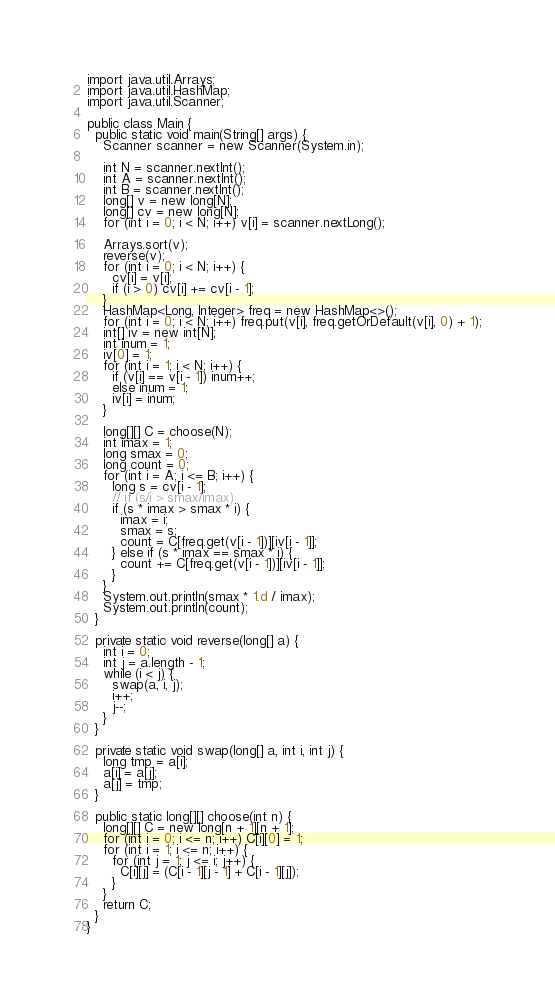Convert code to text. <code><loc_0><loc_0><loc_500><loc_500><_Java_>import java.util.Arrays;
import java.util.HashMap;
import java.util.Scanner;

public class Main {
  public static void main(String[] args) {
    Scanner scanner = new Scanner(System.in);

    int N = scanner.nextInt();
    int A = scanner.nextInt();
    int B = scanner.nextInt();
    long[] v = new long[N];
    long[] cv = new long[N];
    for (int i = 0; i < N; i++) v[i] = scanner.nextLong();

    Arrays.sort(v);
    reverse(v);
    for (int i = 0; i < N; i++) {
      cv[i] = v[i];
      if (i > 0) cv[i] += cv[i - 1];
    }
    HashMap<Long, Integer> freq = new HashMap<>();
    for (int i = 0; i < N; i++) freq.put(v[i], freq.getOrDefault(v[i], 0) + 1);
    int[] iv = new int[N];
    int inum = 1;
    iv[0] = 1;
    for (int i = 1; i < N; i++) {
      if (v[i] == v[i - 1]) inum++;
      else inum = 1;
      iv[i] = inum;
    }

    long[][] C = choose(N);
    int imax = 1;
    long smax = 0;
    long count = 0;
    for (int i = A; i <= B; i++) {
      long s = cv[i - 1];
      // if (s/i > smax/imax)
      if (s * imax > smax * i) {
        imax = i;
        smax = s;
        count = C[freq.get(v[i - 1])][iv[i - 1]];
      } else if (s * imax == smax * i) {
        count += C[freq.get(v[i - 1])][iv[i - 1]];
      }
    }
    System.out.println(smax * 1.d / imax);
    System.out.println(count);
  }

  private static void reverse(long[] a) {
    int i = 0;
    int j = a.length - 1;
    while (i < j) {
      swap(a, i, j);
      i++;
      j--;
    }
  }

  private static void swap(long[] a, int i, int j) {
    long tmp = a[i];
    a[i] = a[j];
    a[j] = tmp;
  }

  public static long[][] choose(int n) {
    long[][] C = new long[n + 1][n + 1];
    for (int i = 0; i <= n; i++) C[i][0] = 1;
    for (int i = 1; i <= n; i++) {
      for (int j = 1; j <= i; j++) {
        C[i][j] = (C[i - 1][j - 1] + C[i - 1][j]);
      }
    }
    return C;
  }
}
</code> 